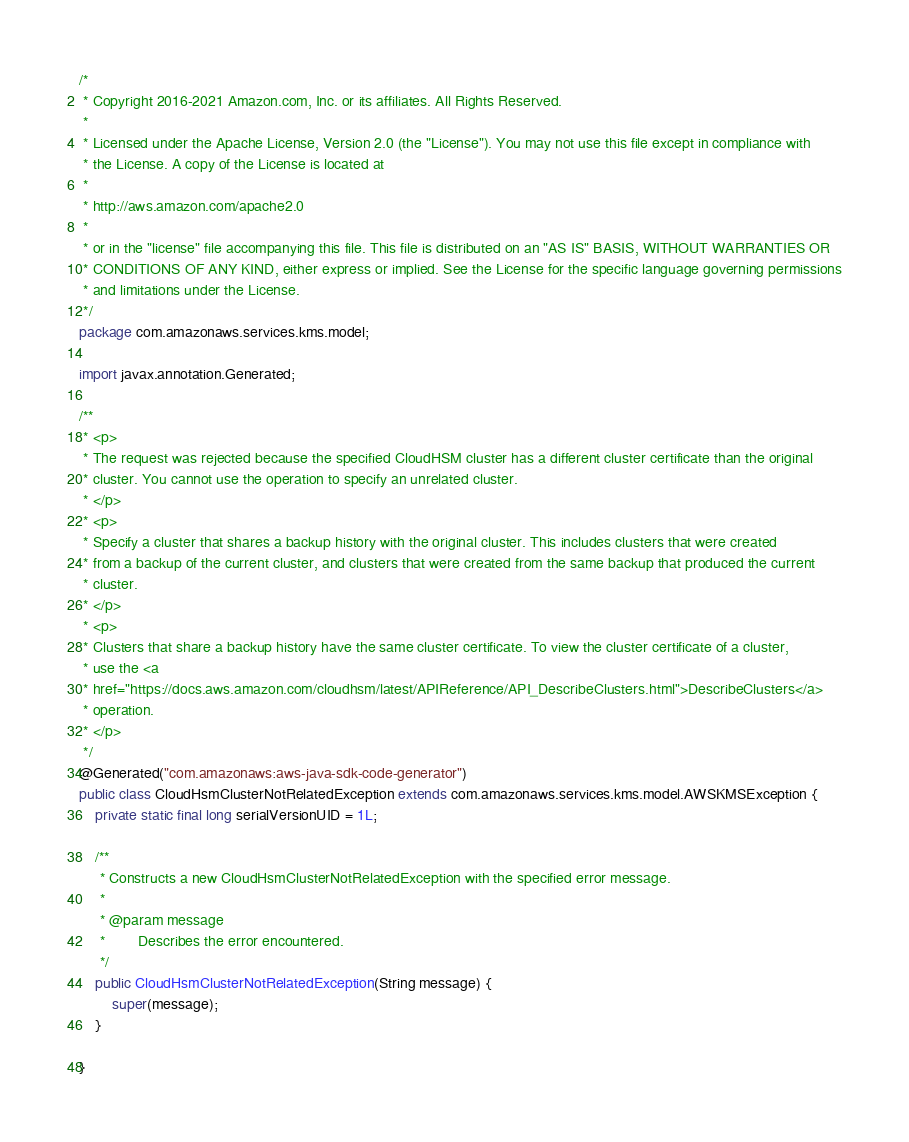Convert code to text. <code><loc_0><loc_0><loc_500><loc_500><_Java_>/*
 * Copyright 2016-2021 Amazon.com, Inc. or its affiliates. All Rights Reserved.
 * 
 * Licensed under the Apache License, Version 2.0 (the "License"). You may not use this file except in compliance with
 * the License. A copy of the License is located at
 * 
 * http://aws.amazon.com/apache2.0
 * 
 * or in the "license" file accompanying this file. This file is distributed on an "AS IS" BASIS, WITHOUT WARRANTIES OR
 * CONDITIONS OF ANY KIND, either express or implied. See the License for the specific language governing permissions
 * and limitations under the License.
 */
package com.amazonaws.services.kms.model;

import javax.annotation.Generated;

/**
 * <p>
 * The request was rejected because the specified CloudHSM cluster has a different cluster certificate than the original
 * cluster. You cannot use the operation to specify an unrelated cluster.
 * </p>
 * <p>
 * Specify a cluster that shares a backup history with the original cluster. This includes clusters that were created
 * from a backup of the current cluster, and clusters that were created from the same backup that produced the current
 * cluster.
 * </p>
 * <p>
 * Clusters that share a backup history have the same cluster certificate. To view the cluster certificate of a cluster,
 * use the <a
 * href="https://docs.aws.amazon.com/cloudhsm/latest/APIReference/API_DescribeClusters.html">DescribeClusters</a>
 * operation.
 * </p>
 */
@Generated("com.amazonaws:aws-java-sdk-code-generator")
public class CloudHsmClusterNotRelatedException extends com.amazonaws.services.kms.model.AWSKMSException {
    private static final long serialVersionUID = 1L;

    /**
     * Constructs a new CloudHsmClusterNotRelatedException with the specified error message.
     *
     * @param message
     *        Describes the error encountered.
     */
    public CloudHsmClusterNotRelatedException(String message) {
        super(message);
    }

}
</code> 